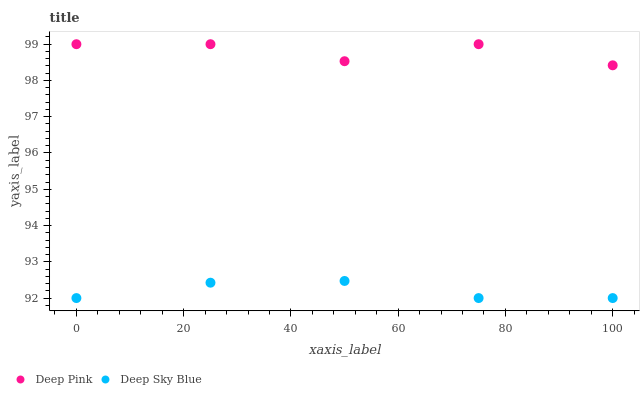Does Deep Sky Blue have the minimum area under the curve?
Answer yes or no. Yes. Does Deep Pink have the maximum area under the curve?
Answer yes or no. Yes. Does Deep Sky Blue have the maximum area under the curve?
Answer yes or no. No. Is Deep Sky Blue the smoothest?
Answer yes or no. Yes. Is Deep Pink the roughest?
Answer yes or no. Yes. Is Deep Sky Blue the roughest?
Answer yes or no. No. Does Deep Sky Blue have the lowest value?
Answer yes or no. Yes. Does Deep Pink have the highest value?
Answer yes or no. Yes. Does Deep Sky Blue have the highest value?
Answer yes or no. No. Is Deep Sky Blue less than Deep Pink?
Answer yes or no. Yes. Is Deep Pink greater than Deep Sky Blue?
Answer yes or no. Yes. Does Deep Sky Blue intersect Deep Pink?
Answer yes or no. No. 